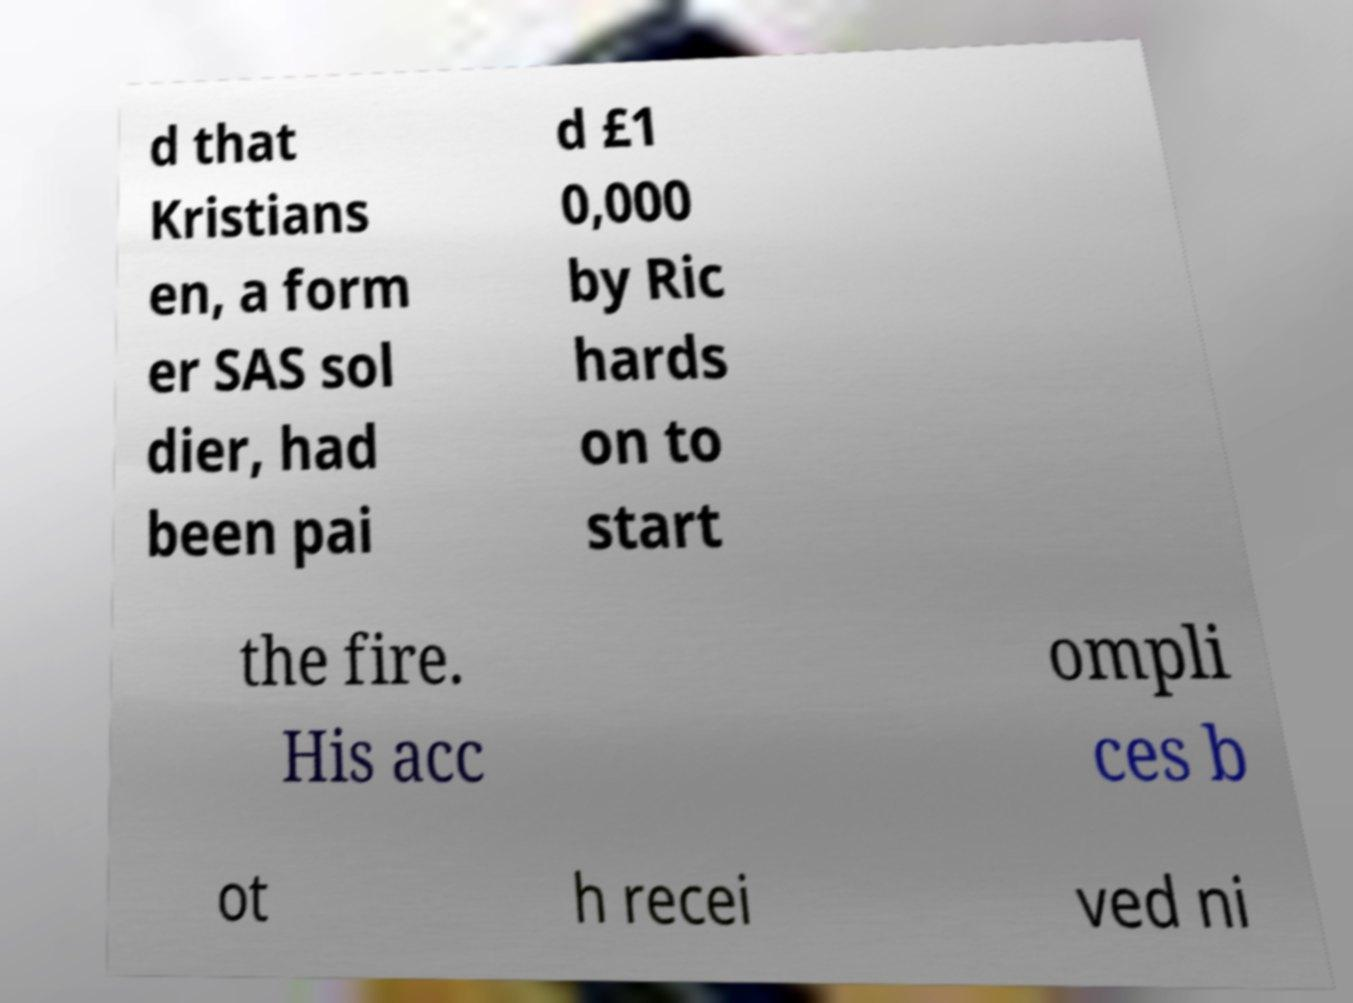Could you extract and type out the text from this image? d that Kristians en, a form er SAS sol dier, had been pai d £1 0,000 by Ric hards on to start the fire. His acc ompli ces b ot h recei ved ni 